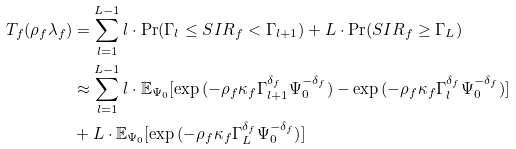<formula> <loc_0><loc_0><loc_500><loc_500>T _ { f } ( \rho _ { f } \lambda _ { f } ) & = \sum _ { l = 1 } ^ { L - 1 } l \cdot \Pr ( \Gamma _ { l } \leq S I R _ { f } < \Gamma _ { l + 1 } ) + L \cdot \Pr ( S I R _ { f } \geq \Gamma _ { L } ) \\ & \approx \sum _ { l = 1 } ^ { L - 1 } l \cdot \mathbb { E } _ { \Psi _ { 0 } } [ \exp { ( - \rho _ { f } \kappa _ { f } \Gamma _ { l + 1 } ^ { \delta _ { f } } \Psi _ { 0 } ^ { - \delta _ { f } } ) } - \exp { ( - \rho _ { f } \kappa _ { f } \Gamma _ { l } ^ { \delta _ { f } } } \Psi _ { 0 } ^ { - \delta _ { f } } ) ] \\ & + L \cdot \mathbb { E } _ { \Psi _ { 0 } } [ \exp { ( - \rho _ { f } \kappa _ { f } \Gamma _ { L } ^ { \delta _ { f } } \Psi _ { 0 } ^ { - \delta _ { f } } ) } ]</formula> 